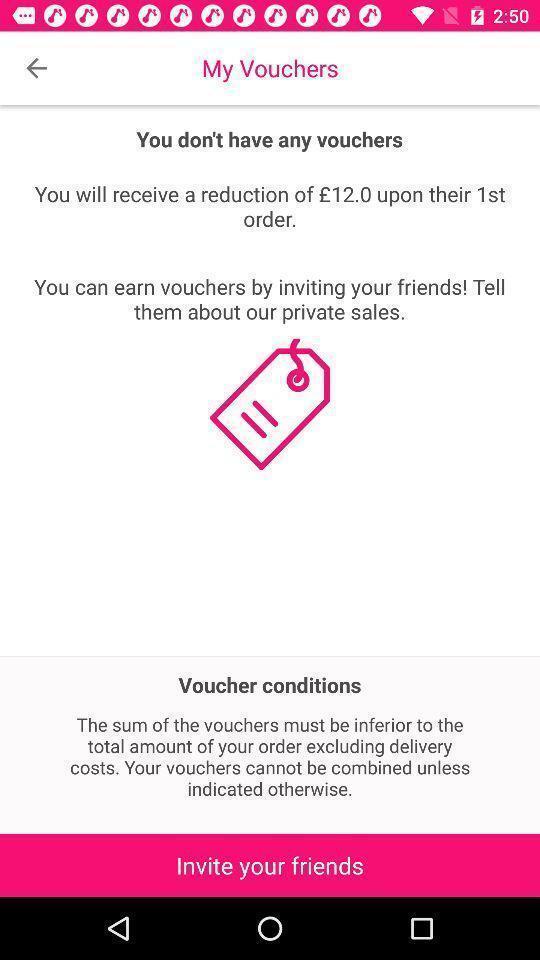Please provide a description for this image. Page showing information about a feature. 